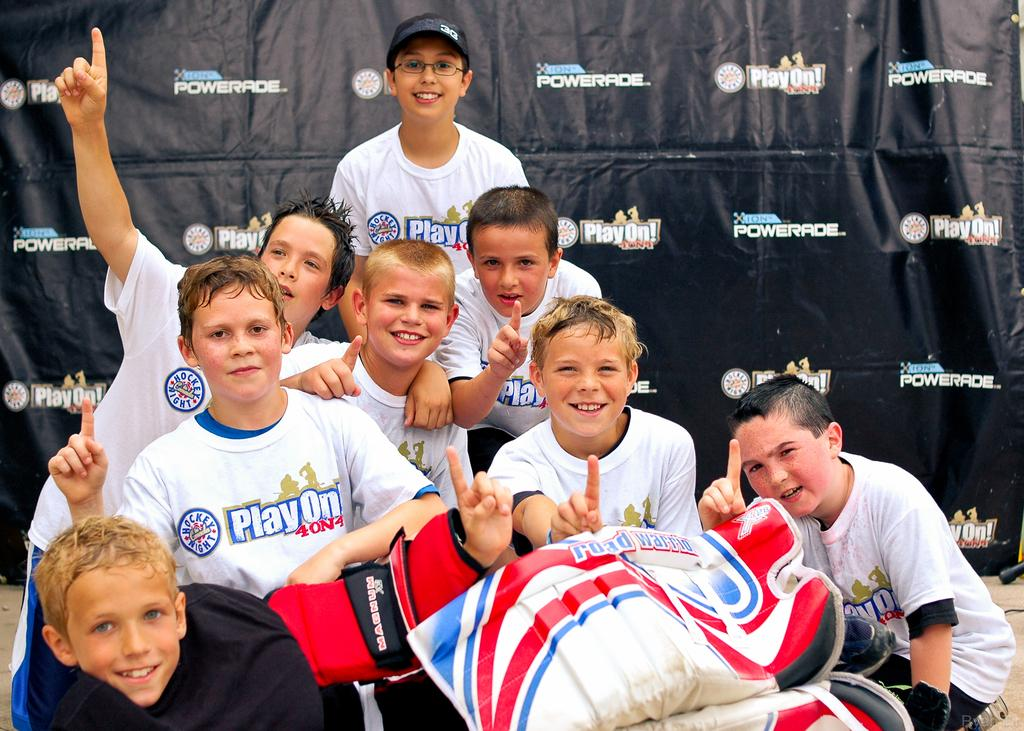What is the main subject of the image? The main subject of the image is a group of children. Can you describe the background of the image? There is a hoarding in the background of the image. What type of collar can be seen on the children in the image? There is no collar visible on the children in the image. What kind of music can be heard in the background of the image? There is no music present in the image; it only features a group of children and a hoarding in the background. 